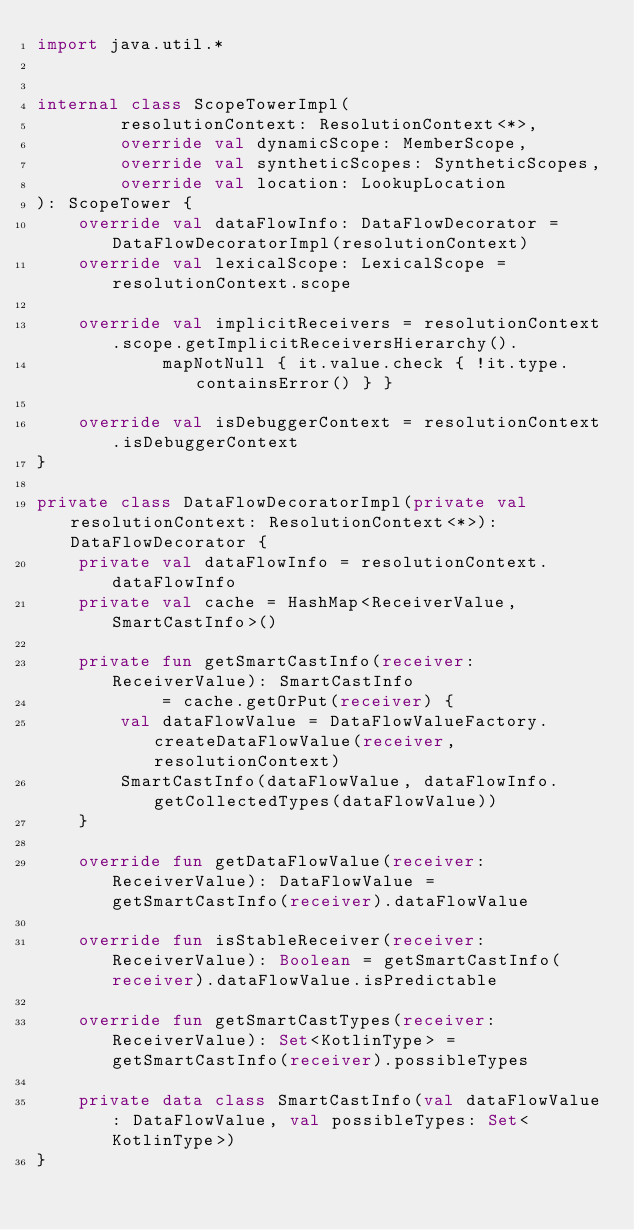<code> <loc_0><loc_0><loc_500><loc_500><_Kotlin_>import java.util.*


internal class ScopeTowerImpl(
        resolutionContext: ResolutionContext<*>,
        override val dynamicScope: MemberScope,
        override val syntheticScopes: SyntheticScopes,
        override val location: LookupLocation
): ScopeTower {
    override val dataFlowInfo: DataFlowDecorator = DataFlowDecoratorImpl(resolutionContext)
    override val lexicalScope: LexicalScope = resolutionContext.scope

    override val implicitReceivers = resolutionContext.scope.getImplicitReceiversHierarchy().
            mapNotNull { it.value.check { !it.type.containsError() } }

    override val isDebuggerContext = resolutionContext.isDebuggerContext
}

private class DataFlowDecoratorImpl(private val resolutionContext: ResolutionContext<*>): DataFlowDecorator {
    private val dataFlowInfo = resolutionContext.dataFlowInfo
    private val cache = HashMap<ReceiverValue, SmartCastInfo>()

    private fun getSmartCastInfo(receiver: ReceiverValue): SmartCastInfo
            = cache.getOrPut(receiver) {
        val dataFlowValue = DataFlowValueFactory.createDataFlowValue(receiver, resolutionContext)
        SmartCastInfo(dataFlowValue, dataFlowInfo.getCollectedTypes(dataFlowValue))
    }

    override fun getDataFlowValue(receiver: ReceiverValue): DataFlowValue = getSmartCastInfo(receiver).dataFlowValue

    override fun isStableReceiver(receiver: ReceiverValue): Boolean = getSmartCastInfo(receiver).dataFlowValue.isPredictable

    override fun getSmartCastTypes(receiver: ReceiverValue): Set<KotlinType> = getSmartCastInfo(receiver).possibleTypes

    private data class SmartCastInfo(val dataFlowValue: DataFlowValue, val possibleTypes: Set<KotlinType>)
}
</code> 